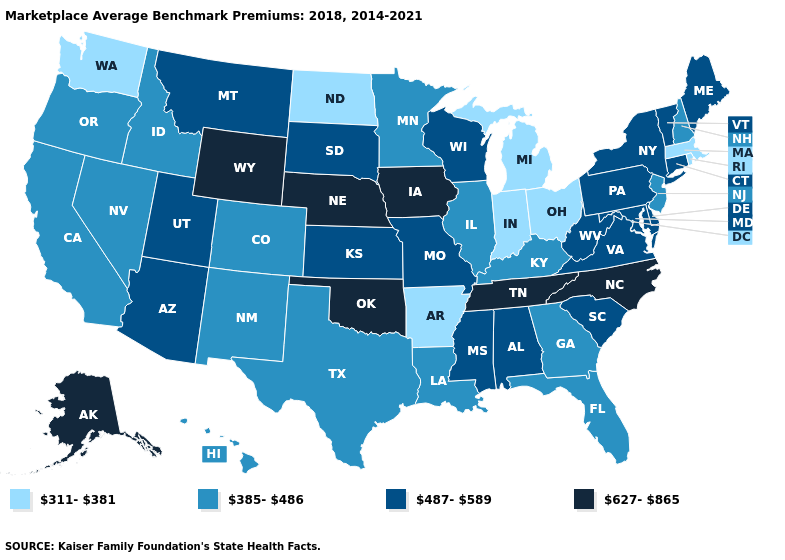Does Oklahoma have a higher value than Arkansas?
Concise answer only. Yes. What is the value of Tennessee?
Write a very short answer. 627-865. Name the states that have a value in the range 311-381?
Write a very short answer. Arkansas, Indiana, Massachusetts, Michigan, North Dakota, Ohio, Rhode Island, Washington. Does the map have missing data?
Keep it brief. No. Does Arkansas have the lowest value in the South?
Keep it brief. Yes. Among the states that border Oregon , does Idaho have the lowest value?
Be succinct. No. Among the states that border Minnesota , which have the lowest value?
Be succinct. North Dakota. What is the value of Oregon?
Answer briefly. 385-486. What is the lowest value in the USA?
Be succinct. 311-381. What is the value of Montana?
Short answer required. 487-589. Which states have the highest value in the USA?
Give a very brief answer. Alaska, Iowa, Nebraska, North Carolina, Oklahoma, Tennessee, Wyoming. What is the lowest value in states that border Oregon?
Write a very short answer. 311-381. What is the highest value in states that border New Hampshire?
Keep it brief. 487-589. Among the states that border Ohio , does Pennsylvania have the lowest value?
Keep it brief. No. Name the states that have a value in the range 385-486?
Answer briefly. California, Colorado, Florida, Georgia, Hawaii, Idaho, Illinois, Kentucky, Louisiana, Minnesota, Nevada, New Hampshire, New Jersey, New Mexico, Oregon, Texas. 